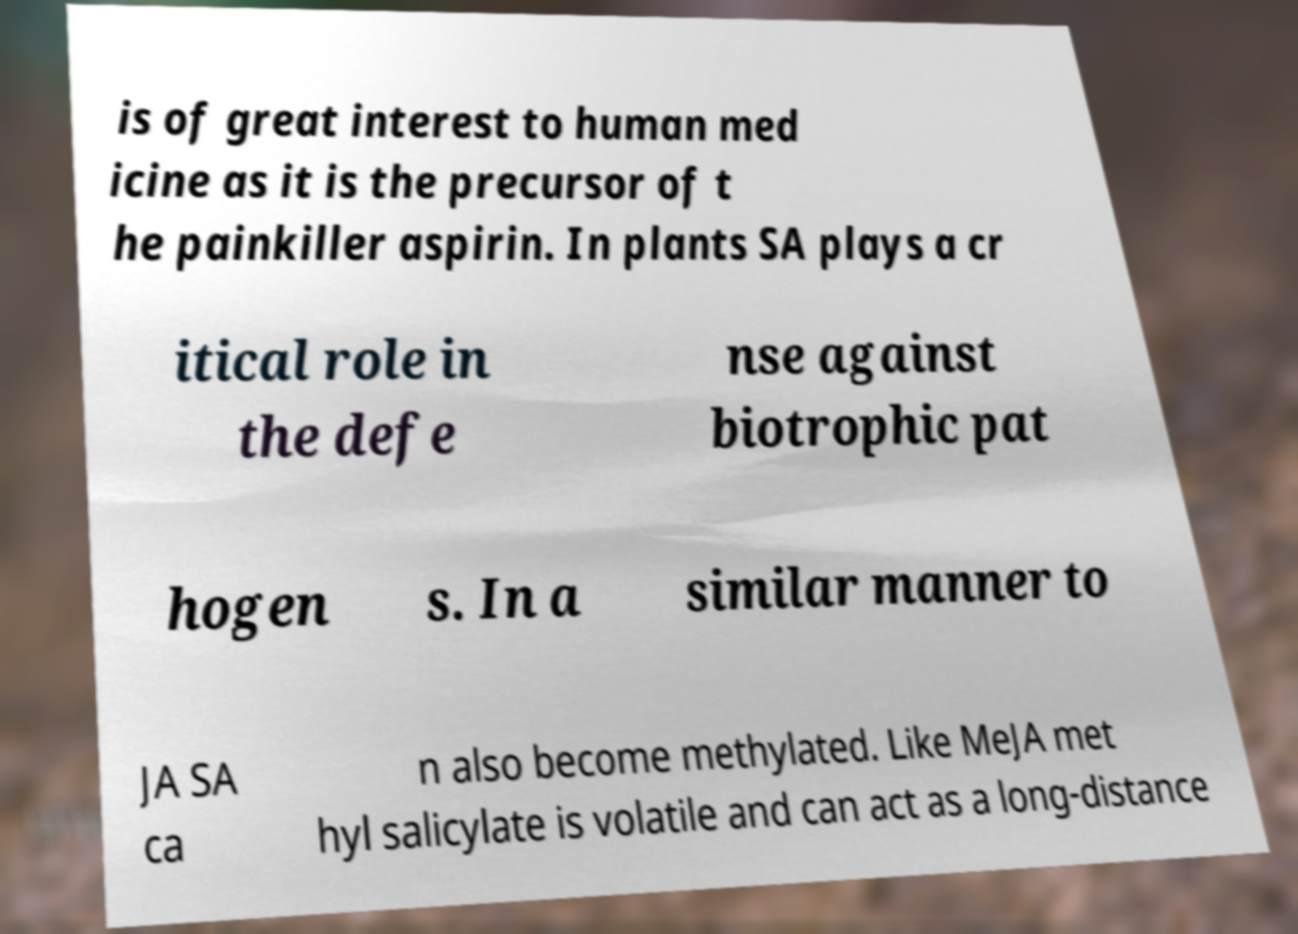Could you assist in decoding the text presented in this image and type it out clearly? is of great interest to human med icine as it is the precursor of t he painkiller aspirin. In plants SA plays a cr itical role in the defe nse against biotrophic pat hogen s. In a similar manner to JA SA ca n also become methylated. Like MeJA met hyl salicylate is volatile and can act as a long-distance 